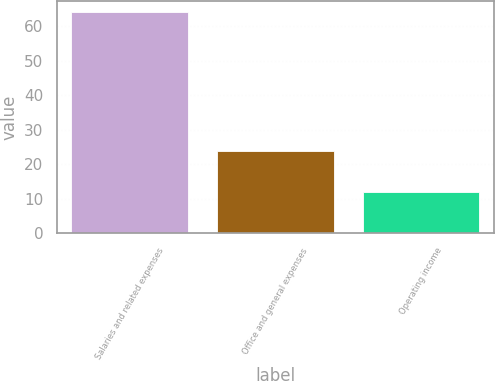<chart> <loc_0><loc_0><loc_500><loc_500><bar_chart><fcel>Salaries and related expenses<fcel>Office and general expenses<fcel>Operating income<nl><fcel>64.2<fcel>23.8<fcel>12<nl></chart> 